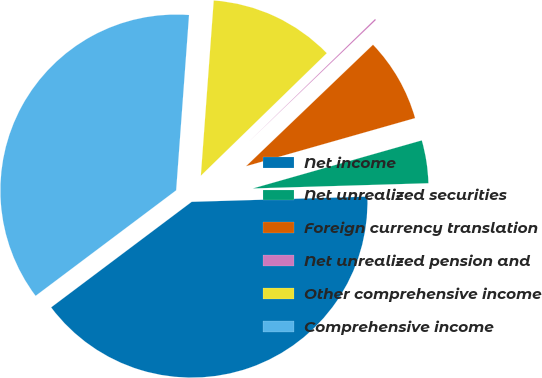Convert chart to OTSL. <chart><loc_0><loc_0><loc_500><loc_500><pie_chart><fcel>Net income<fcel>Net unrealized securities<fcel>Foreign currency translation<fcel>Net unrealized pension and<fcel>Other comprehensive income<fcel>Comprehensive income<nl><fcel>40.22%<fcel>3.94%<fcel>7.74%<fcel>0.13%<fcel>11.55%<fcel>36.42%<nl></chart> 